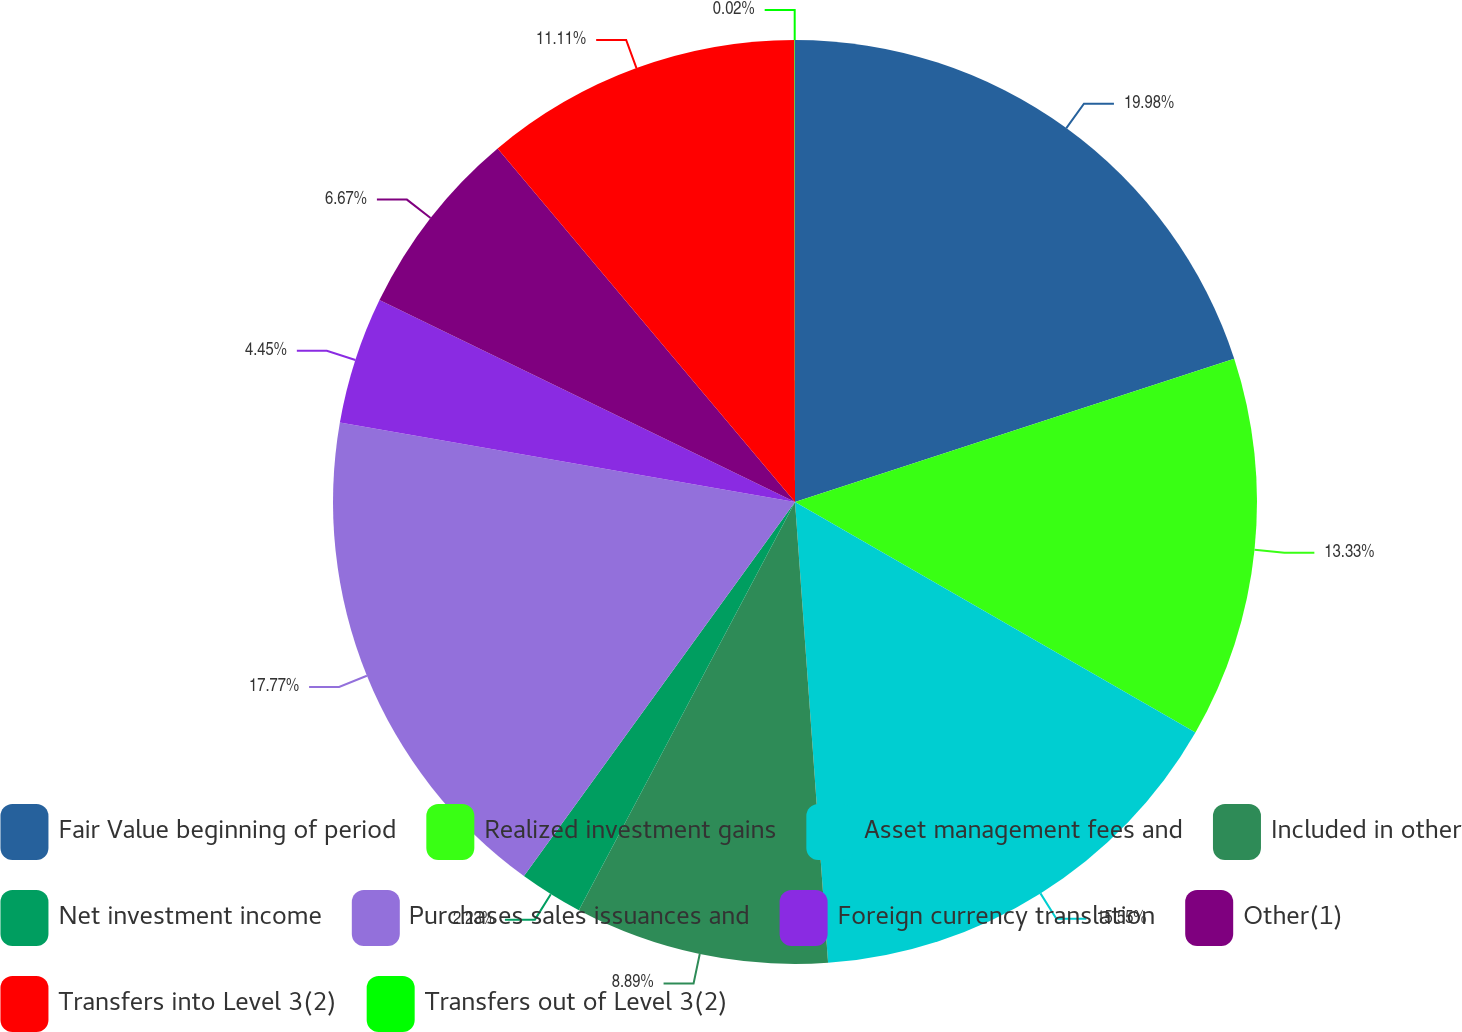<chart> <loc_0><loc_0><loc_500><loc_500><pie_chart><fcel>Fair Value beginning of period<fcel>Realized investment gains<fcel>Asset management fees and<fcel>Included in other<fcel>Net investment income<fcel>Purchases sales issuances and<fcel>Foreign currency translation<fcel>Other(1)<fcel>Transfers into Level 3(2)<fcel>Transfers out of Level 3(2)<nl><fcel>19.98%<fcel>13.33%<fcel>15.55%<fcel>8.89%<fcel>2.23%<fcel>17.77%<fcel>4.45%<fcel>6.67%<fcel>11.11%<fcel>0.02%<nl></chart> 